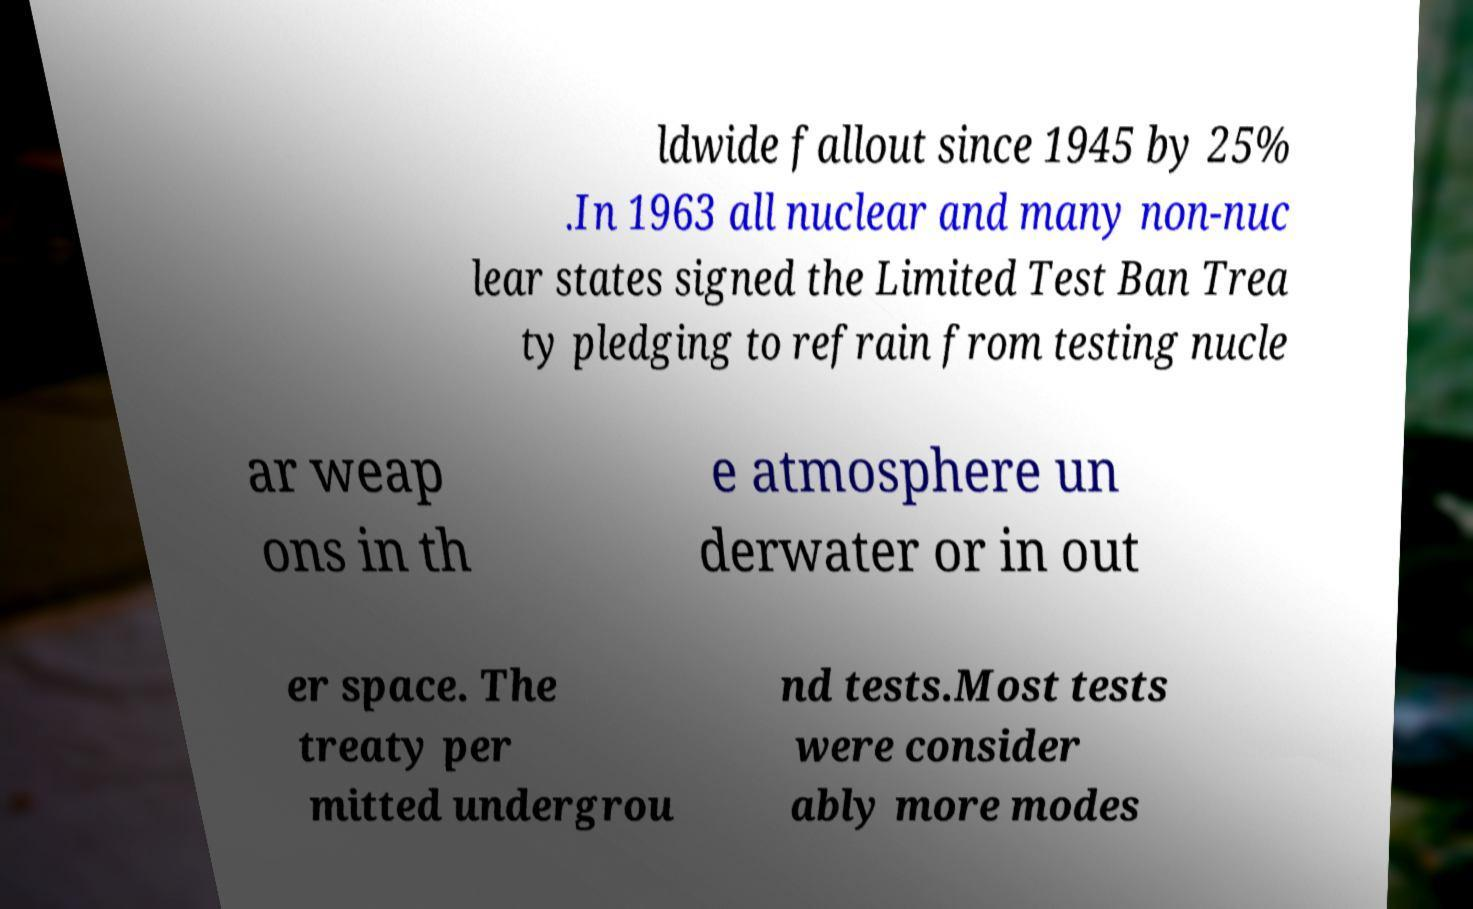Please read and relay the text visible in this image. What does it say? ldwide fallout since 1945 by 25% .In 1963 all nuclear and many non-nuc lear states signed the Limited Test Ban Trea ty pledging to refrain from testing nucle ar weap ons in th e atmosphere un derwater or in out er space. The treaty per mitted undergrou nd tests.Most tests were consider ably more modes 